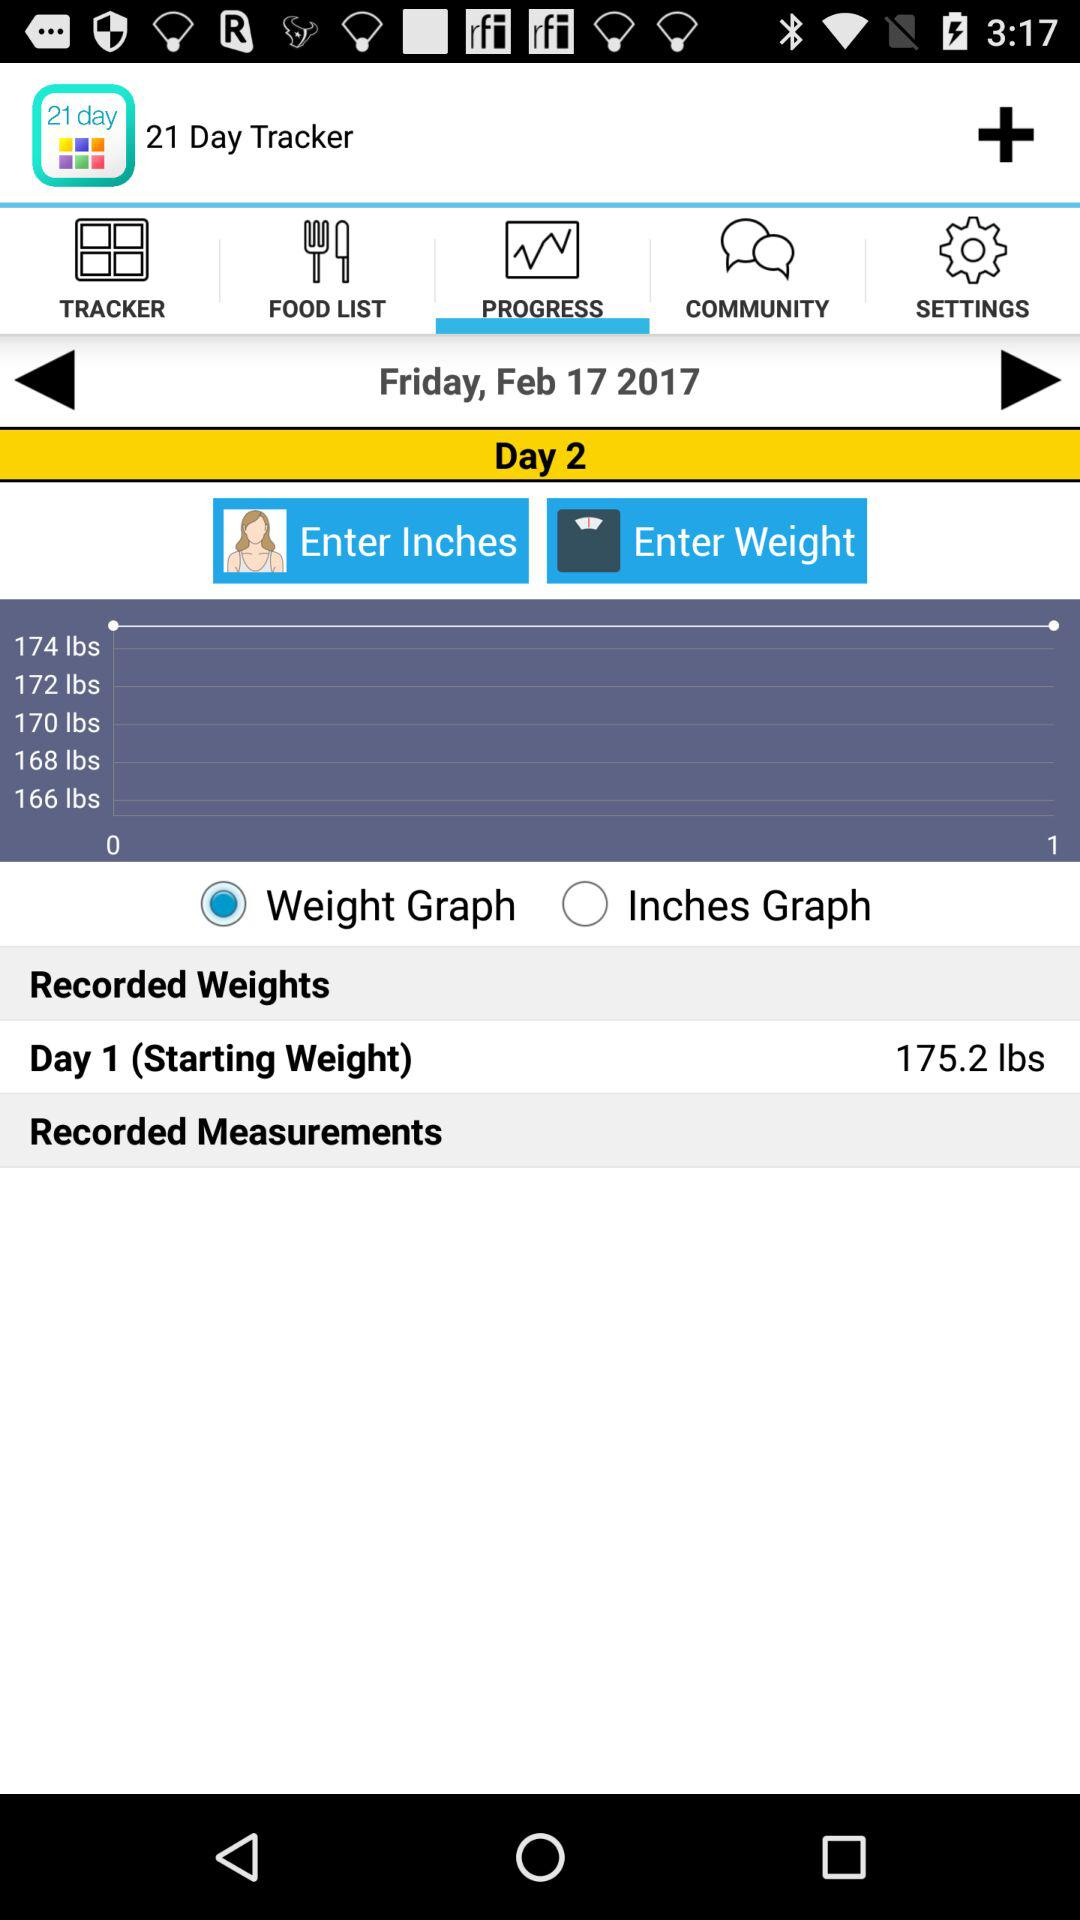How many items are in "COMMUNITY"?
When the provided information is insufficient, respond with <no answer>. <no answer> 